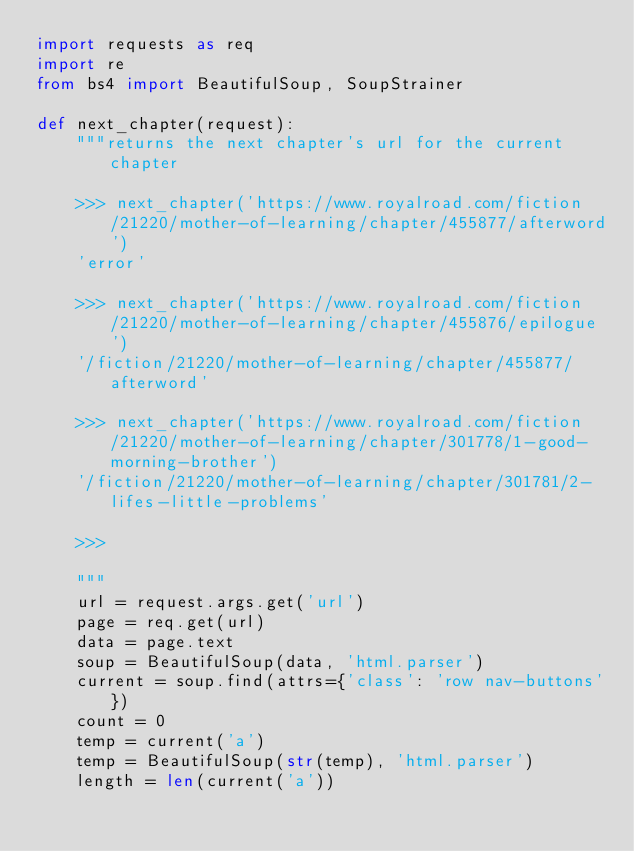Convert code to text. <code><loc_0><loc_0><loc_500><loc_500><_Python_>import requests as req
import re
from bs4 import BeautifulSoup, SoupStrainer

def next_chapter(request):
    """returns the next chapter's url for the current chapter

    >>> next_chapter('https://www.royalroad.com/fiction/21220/mother-of-learning/chapter/455877/afterword')
    'error'

    >>> next_chapter('https://www.royalroad.com/fiction/21220/mother-of-learning/chapter/455876/epilogue')
    '/fiction/21220/mother-of-learning/chapter/455877/afterword'

    >>> next_chapter('https://www.royalroad.com/fiction/21220/mother-of-learning/chapter/301778/1-good-morning-brother')
    '/fiction/21220/mother-of-learning/chapter/301781/2-lifes-little-problems'

    >>>

    """
    url = request.args.get('url')
    page = req.get(url)
    data = page.text
    soup = BeautifulSoup(data, 'html.parser')
    current = soup.find(attrs={'class': 'row nav-buttons'})
    count = 0
    temp = current('a')
    temp = BeautifulSoup(str(temp), 'html.parser')
    length = len(current('a'))</code> 